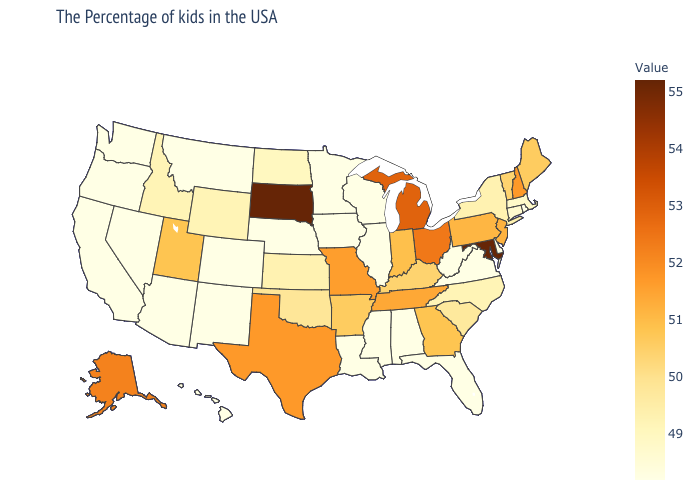Does Indiana have a lower value than Idaho?
Give a very brief answer. No. Which states have the lowest value in the USA?
Concise answer only. Rhode Island, Delaware, Virginia, West Virginia, Florida, Alabama, Wisconsin, Illinois, Mississippi, Louisiana, Minnesota, Iowa, Nebraska, Colorado, New Mexico, Montana, Arizona, Nevada, California, Washington, Oregon, Hawaii. Among the states that border Arizona , which have the highest value?
Answer briefly. Utah. Does Alaska have the lowest value in the West?
Keep it brief. No. Which states have the highest value in the USA?
Quick response, please. Maryland, South Dakota. Does South Dakota have the highest value in the USA?
Answer briefly. Yes. 